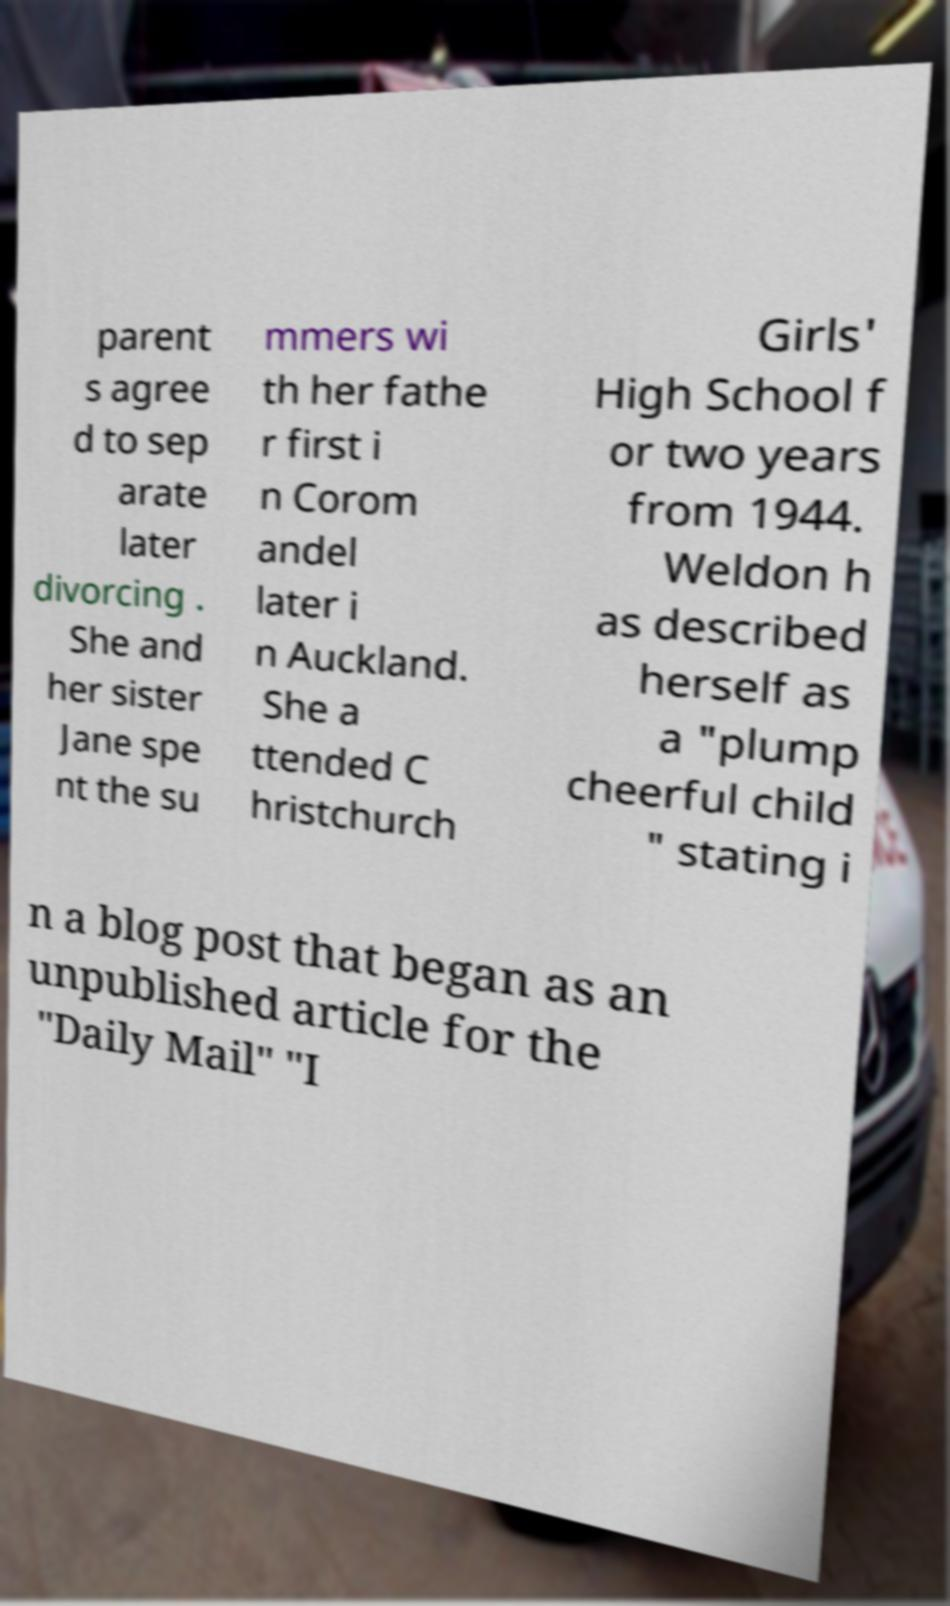What messages or text are displayed in this image? I need them in a readable, typed format. parent s agree d to sep arate later divorcing . She and her sister Jane spe nt the su mmers wi th her fathe r first i n Corom andel later i n Auckland. She a ttended C hristchurch Girls' High School f or two years from 1944. Weldon h as described herself as a "plump cheerful child " stating i n a blog post that began as an unpublished article for the "Daily Mail" "I 